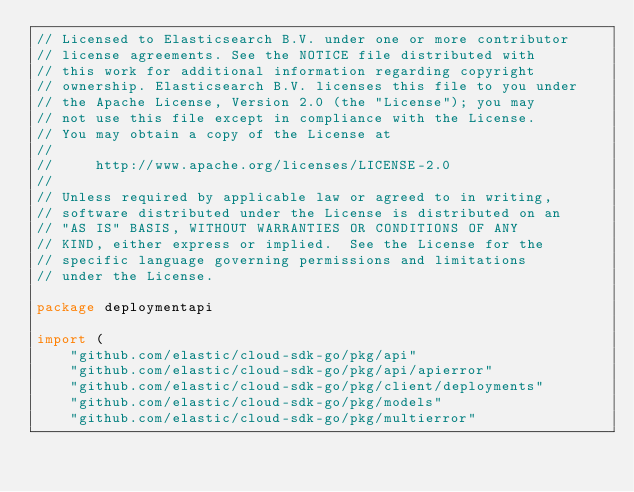<code> <loc_0><loc_0><loc_500><loc_500><_Go_>// Licensed to Elasticsearch B.V. under one or more contributor
// license agreements. See the NOTICE file distributed with
// this work for additional information regarding copyright
// ownership. Elasticsearch B.V. licenses this file to you under
// the Apache License, Version 2.0 (the "License"); you may
// not use this file except in compliance with the License.
// You may obtain a copy of the License at
//
//     http://www.apache.org/licenses/LICENSE-2.0
//
// Unless required by applicable law or agreed to in writing,
// software distributed under the License is distributed on an
// "AS IS" BASIS, WITHOUT WARRANTIES OR CONDITIONS OF ANY
// KIND, either express or implied.  See the License for the
// specific language governing permissions and limitations
// under the License.

package deploymentapi

import (
	"github.com/elastic/cloud-sdk-go/pkg/api"
	"github.com/elastic/cloud-sdk-go/pkg/api/apierror"
	"github.com/elastic/cloud-sdk-go/pkg/client/deployments"
	"github.com/elastic/cloud-sdk-go/pkg/models"
	"github.com/elastic/cloud-sdk-go/pkg/multierror"</code> 